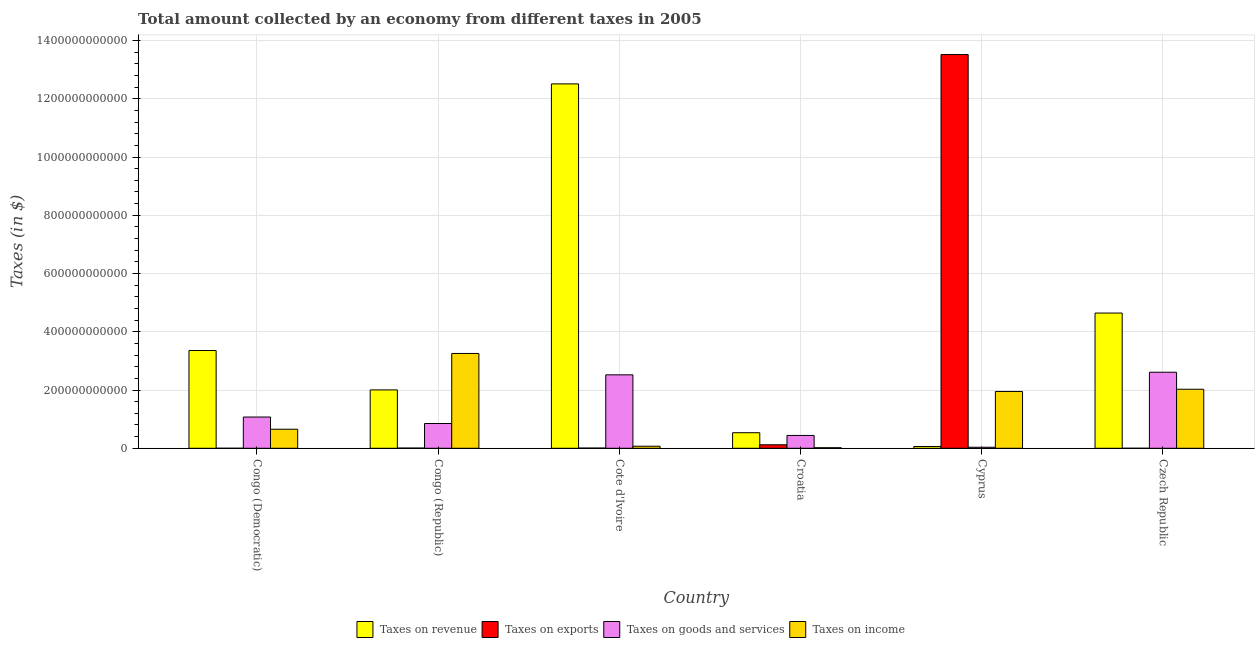How many different coloured bars are there?
Provide a succinct answer. 4. Are the number of bars per tick equal to the number of legend labels?
Ensure brevity in your answer.  Yes. Are the number of bars on each tick of the X-axis equal?
Make the answer very short. Yes. What is the label of the 4th group of bars from the left?
Ensure brevity in your answer.  Croatia. What is the amount collected as tax on income in Croatia?
Your answer should be compact. 1.96e+09. Across all countries, what is the maximum amount collected as tax on goods?
Make the answer very short. 2.61e+11. Across all countries, what is the minimum amount collected as tax on exports?
Give a very brief answer. 1.00e+06. In which country was the amount collected as tax on exports maximum?
Provide a short and direct response. Cyprus. In which country was the amount collected as tax on exports minimum?
Your answer should be compact. Czech Republic. What is the total amount collected as tax on exports in the graph?
Give a very brief answer. 1.37e+12. What is the difference between the amount collected as tax on goods in Congo (Democratic) and that in Czech Republic?
Keep it short and to the point. -1.54e+11. What is the difference between the amount collected as tax on exports in Congo (Republic) and the amount collected as tax on goods in Cyprus?
Offer a very short reply. -2.79e+09. What is the average amount collected as tax on revenue per country?
Your answer should be very brief. 3.85e+11. What is the difference between the amount collected as tax on income and amount collected as tax on revenue in Congo (Republic)?
Offer a very short reply. 1.25e+11. What is the ratio of the amount collected as tax on income in Croatia to that in Czech Republic?
Your answer should be very brief. 0.01. Is the amount collected as tax on exports in Cote d'Ivoire less than that in Cyprus?
Provide a short and direct response. Yes. Is the difference between the amount collected as tax on revenue in Cote d'Ivoire and Croatia greater than the difference between the amount collected as tax on exports in Cote d'Ivoire and Croatia?
Keep it short and to the point. Yes. What is the difference between the highest and the second highest amount collected as tax on goods?
Give a very brief answer. 8.94e+09. What is the difference between the highest and the lowest amount collected as tax on goods?
Ensure brevity in your answer.  2.58e+11. Is the sum of the amount collected as tax on income in Cote d'Ivoire and Cyprus greater than the maximum amount collected as tax on exports across all countries?
Provide a succinct answer. No. What does the 1st bar from the left in Cyprus represents?
Provide a short and direct response. Taxes on revenue. What does the 3rd bar from the right in Croatia represents?
Your answer should be very brief. Taxes on exports. Is it the case that in every country, the sum of the amount collected as tax on revenue and amount collected as tax on exports is greater than the amount collected as tax on goods?
Your answer should be compact. Yes. How many bars are there?
Your answer should be very brief. 24. What is the difference between two consecutive major ticks on the Y-axis?
Your answer should be very brief. 2.00e+11. Are the values on the major ticks of Y-axis written in scientific E-notation?
Provide a short and direct response. No. How are the legend labels stacked?
Offer a terse response. Horizontal. What is the title of the graph?
Provide a succinct answer. Total amount collected by an economy from different taxes in 2005. Does "Rule based governance" appear as one of the legend labels in the graph?
Your response must be concise. No. What is the label or title of the X-axis?
Keep it short and to the point. Country. What is the label or title of the Y-axis?
Provide a short and direct response. Taxes (in $). What is the Taxes (in $) in Taxes on revenue in Congo (Democratic)?
Offer a terse response. 3.36e+11. What is the Taxes (in $) in Taxes on exports in Congo (Democratic)?
Keep it short and to the point. 8.52e+06. What is the Taxes (in $) in Taxes on goods and services in Congo (Democratic)?
Provide a short and direct response. 1.07e+11. What is the Taxes (in $) in Taxes on income in Congo (Democratic)?
Your answer should be very brief. 6.54e+1. What is the Taxes (in $) of Taxes on revenue in Congo (Republic)?
Offer a very short reply. 2.00e+11. What is the Taxes (in $) of Taxes on exports in Congo (Republic)?
Your answer should be very brief. 7.10e+08. What is the Taxes (in $) in Taxes on goods and services in Congo (Republic)?
Ensure brevity in your answer.  8.51e+1. What is the Taxes (in $) of Taxes on income in Congo (Republic)?
Offer a terse response. 3.26e+11. What is the Taxes (in $) of Taxes on revenue in Cote d'Ivoire?
Provide a short and direct response. 1.25e+12. What is the Taxes (in $) in Taxes on exports in Cote d'Ivoire?
Offer a terse response. 6.98e+08. What is the Taxes (in $) of Taxes on goods and services in Cote d'Ivoire?
Give a very brief answer. 2.52e+11. What is the Taxes (in $) of Taxes on income in Cote d'Ivoire?
Keep it short and to the point. 7.06e+09. What is the Taxes (in $) in Taxes on revenue in Croatia?
Your answer should be compact. 5.34e+1. What is the Taxes (in $) of Taxes on exports in Croatia?
Offer a terse response. 1.20e+1. What is the Taxes (in $) in Taxes on goods and services in Croatia?
Provide a succinct answer. 4.41e+1. What is the Taxes (in $) of Taxes on income in Croatia?
Provide a short and direct response. 1.96e+09. What is the Taxes (in $) in Taxes on revenue in Cyprus?
Provide a succinct answer. 6.12e+09. What is the Taxes (in $) of Taxes on exports in Cyprus?
Your response must be concise. 1.35e+12. What is the Taxes (in $) of Taxes on goods and services in Cyprus?
Keep it short and to the point. 3.50e+09. What is the Taxes (in $) of Taxes on income in Cyprus?
Provide a short and direct response. 1.95e+11. What is the Taxes (in $) in Taxes on revenue in Czech Republic?
Provide a succinct answer. 4.64e+11. What is the Taxes (in $) in Taxes on exports in Czech Republic?
Offer a terse response. 1.00e+06. What is the Taxes (in $) in Taxes on goods and services in Czech Republic?
Offer a very short reply. 2.61e+11. What is the Taxes (in $) in Taxes on income in Czech Republic?
Keep it short and to the point. 2.03e+11. Across all countries, what is the maximum Taxes (in $) of Taxes on revenue?
Keep it short and to the point. 1.25e+12. Across all countries, what is the maximum Taxes (in $) of Taxes on exports?
Your answer should be compact. 1.35e+12. Across all countries, what is the maximum Taxes (in $) in Taxes on goods and services?
Provide a succinct answer. 2.61e+11. Across all countries, what is the maximum Taxes (in $) in Taxes on income?
Provide a succinct answer. 3.26e+11. Across all countries, what is the minimum Taxes (in $) of Taxes on revenue?
Provide a succinct answer. 6.12e+09. Across all countries, what is the minimum Taxes (in $) of Taxes on exports?
Offer a very short reply. 1.00e+06. Across all countries, what is the minimum Taxes (in $) of Taxes on goods and services?
Make the answer very short. 3.50e+09. Across all countries, what is the minimum Taxes (in $) of Taxes on income?
Give a very brief answer. 1.96e+09. What is the total Taxes (in $) of Taxes on revenue in the graph?
Provide a succinct answer. 2.31e+12. What is the total Taxes (in $) of Taxes on exports in the graph?
Keep it short and to the point. 1.37e+12. What is the total Taxes (in $) in Taxes on goods and services in the graph?
Your answer should be very brief. 7.53e+11. What is the total Taxes (in $) of Taxes on income in the graph?
Your answer should be compact. 7.98e+11. What is the difference between the Taxes (in $) in Taxes on revenue in Congo (Democratic) and that in Congo (Republic)?
Ensure brevity in your answer.  1.35e+11. What is the difference between the Taxes (in $) in Taxes on exports in Congo (Democratic) and that in Congo (Republic)?
Keep it short and to the point. -7.01e+08. What is the difference between the Taxes (in $) in Taxes on goods and services in Congo (Democratic) and that in Congo (Republic)?
Your answer should be compact. 2.23e+1. What is the difference between the Taxes (in $) of Taxes on income in Congo (Democratic) and that in Congo (Republic)?
Your answer should be compact. -2.60e+11. What is the difference between the Taxes (in $) in Taxes on revenue in Congo (Democratic) and that in Cote d'Ivoire?
Your answer should be compact. -9.15e+11. What is the difference between the Taxes (in $) of Taxes on exports in Congo (Democratic) and that in Cote d'Ivoire?
Make the answer very short. -6.89e+08. What is the difference between the Taxes (in $) in Taxes on goods and services in Congo (Democratic) and that in Cote d'Ivoire?
Keep it short and to the point. -1.45e+11. What is the difference between the Taxes (in $) in Taxes on income in Congo (Democratic) and that in Cote d'Ivoire?
Keep it short and to the point. 5.84e+1. What is the difference between the Taxes (in $) in Taxes on revenue in Congo (Democratic) and that in Croatia?
Provide a short and direct response. 2.82e+11. What is the difference between the Taxes (in $) in Taxes on exports in Congo (Democratic) and that in Croatia?
Make the answer very short. -1.20e+1. What is the difference between the Taxes (in $) in Taxes on goods and services in Congo (Democratic) and that in Croatia?
Ensure brevity in your answer.  6.32e+1. What is the difference between the Taxes (in $) in Taxes on income in Congo (Democratic) and that in Croatia?
Ensure brevity in your answer.  6.35e+1. What is the difference between the Taxes (in $) in Taxes on revenue in Congo (Democratic) and that in Cyprus?
Ensure brevity in your answer.  3.30e+11. What is the difference between the Taxes (in $) in Taxes on exports in Congo (Democratic) and that in Cyprus?
Your response must be concise. -1.35e+12. What is the difference between the Taxes (in $) of Taxes on goods and services in Congo (Democratic) and that in Cyprus?
Provide a succinct answer. 1.04e+11. What is the difference between the Taxes (in $) in Taxes on income in Congo (Democratic) and that in Cyprus?
Your answer should be compact. -1.30e+11. What is the difference between the Taxes (in $) of Taxes on revenue in Congo (Democratic) and that in Czech Republic?
Make the answer very short. -1.29e+11. What is the difference between the Taxes (in $) of Taxes on exports in Congo (Democratic) and that in Czech Republic?
Offer a terse response. 7.52e+06. What is the difference between the Taxes (in $) in Taxes on goods and services in Congo (Democratic) and that in Czech Republic?
Provide a succinct answer. -1.54e+11. What is the difference between the Taxes (in $) of Taxes on income in Congo (Democratic) and that in Czech Republic?
Your answer should be very brief. -1.37e+11. What is the difference between the Taxes (in $) of Taxes on revenue in Congo (Republic) and that in Cote d'Ivoire?
Your answer should be very brief. -1.05e+12. What is the difference between the Taxes (in $) of Taxes on exports in Congo (Republic) and that in Cote d'Ivoire?
Give a very brief answer. 1.20e+07. What is the difference between the Taxes (in $) in Taxes on goods and services in Congo (Republic) and that in Cote d'Ivoire?
Make the answer very short. -1.67e+11. What is the difference between the Taxes (in $) in Taxes on income in Congo (Republic) and that in Cote d'Ivoire?
Your response must be concise. 3.19e+11. What is the difference between the Taxes (in $) in Taxes on revenue in Congo (Republic) and that in Croatia?
Your response must be concise. 1.47e+11. What is the difference between the Taxes (in $) of Taxes on exports in Congo (Republic) and that in Croatia?
Offer a very short reply. -1.13e+1. What is the difference between the Taxes (in $) of Taxes on goods and services in Congo (Republic) and that in Croatia?
Provide a succinct answer. 4.10e+1. What is the difference between the Taxes (in $) in Taxes on income in Congo (Republic) and that in Croatia?
Provide a succinct answer. 3.24e+11. What is the difference between the Taxes (in $) in Taxes on revenue in Congo (Republic) and that in Cyprus?
Ensure brevity in your answer.  1.94e+11. What is the difference between the Taxes (in $) of Taxes on exports in Congo (Republic) and that in Cyprus?
Keep it short and to the point. -1.35e+12. What is the difference between the Taxes (in $) in Taxes on goods and services in Congo (Republic) and that in Cyprus?
Provide a short and direct response. 8.16e+1. What is the difference between the Taxes (in $) of Taxes on income in Congo (Republic) and that in Cyprus?
Provide a succinct answer. 1.31e+11. What is the difference between the Taxes (in $) of Taxes on revenue in Congo (Republic) and that in Czech Republic?
Provide a succinct answer. -2.64e+11. What is the difference between the Taxes (in $) in Taxes on exports in Congo (Republic) and that in Czech Republic?
Offer a very short reply. 7.09e+08. What is the difference between the Taxes (in $) of Taxes on goods and services in Congo (Republic) and that in Czech Republic?
Offer a very short reply. -1.76e+11. What is the difference between the Taxes (in $) in Taxes on income in Congo (Republic) and that in Czech Republic?
Provide a succinct answer. 1.23e+11. What is the difference between the Taxes (in $) in Taxes on revenue in Cote d'Ivoire and that in Croatia?
Your answer should be compact. 1.20e+12. What is the difference between the Taxes (in $) of Taxes on exports in Cote d'Ivoire and that in Croatia?
Keep it short and to the point. -1.13e+1. What is the difference between the Taxes (in $) in Taxes on goods and services in Cote d'Ivoire and that in Croatia?
Your response must be concise. 2.08e+11. What is the difference between the Taxes (in $) of Taxes on income in Cote d'Ivoire and that in Croatia?
Give a very brief answer. 5.10e+09. What is the difference between the Taxes (in $) of Taxes on revenue in Cote d'Ivoire and that in Cyprus?
Ensure brevity in your answer.  1.25e+12. What is the difference between the Taxes (in $) of Taxes on exports in Cote d'Ivoire and that in Cyprus?
Give a very brief answer. -1.35e+12. What is the difference between the Taxes (in $) in Taxes on goods and services in Cote d'Ivoire and that in Cyprus?
Offer a terse response. 2.49e+11. What is the difference between the Taxes (in $) of Taxes on income in Cote d'Ivoire and that in Cyprus?
Ensure brevity in your answer.  -1.88e+11. What is the difference between the Taxes (in $) in Taxes on revenue in Cote d'Ivoire and that in Czech Republic?
Provide a short and direct response. 7.87e+11. What is the difference between the Taxes (in $) of Taxes on exports in Cote d'Ivoire and that in Czech Republic?
Give a very brief answer. 6.97e+08. What is the difference between the Taxes (in $) in Taxes on goods and services in Cote d'Ivoire and that in Czech Republic?
Offer a very short reply. -8.94e+09. What is the difference between the Taxes (in $) of Taxes on income in Cote d'Ivoire and that in Czech Republic?
Ensure brevity in your answer.  -1.96e+11. What is the difference between the Taxes (in $) of Taxes on revenue in Croatia and that in Cyprus?
Keep it short and to the point. 4.73e+1. What is the difference between the Taxes (in $) in Taxes on exports in Croatia and that in Cyprus?
Your answer should be very brief. -1.34e+12. What is the difference between the Taxes (in $) in Taxes on goods and services in Croatia and that in Cyprus?
Ensure brevity in your answer.  4.06e+1. What is the difference between the Taxes (in $) in Taxes on income in Croatia and that in Cyprus?
Your answer should be very brief. -1.93e+11. What is the difference between the Taxes (in $) in Taxes on revenue in Croatia and that in Czech Republic?
Ensure brevity in your answer.  -4.11e+11. What is the difference between the Taxes (in $) of Taxes on exports in Croatia and that in Czech Republic?
Make the answer very short. 1.20e+1. What is the difference between the Taxes (in $) of Taxes on goods and services in Croatia and that in Czech Republic?
Your answer should be very brief. -2.17e+11. What is the difference between the Taxes (in $) in Taxes on income in Croatia and that in Czech Republic?
Offer a very short reply. -2.01e+11. What is the difference between the Taxes (in $) in Taxes on revenue in Cyprus and that in Czech Republic?
Provide a short and direct response. -4.58e+11. What is the difference between the Taxes (in $) in Taxes on exports in Cyprus and that in Czech Republic?
Your answer should be compact. 1.35e+12. What is the difference between the Taxes (in $) in Taxes on goods and services in Cyprus and that in Czech Republic?
Your answer should be very brief. -2.58e+11. What is the difference between the Taxes (in $) in Taxes on income in Cyprus and that in Czech Republic?
Provide a short and direct response. -7.66e+09. What is the difference between the Taxes (in $) in Taxes on revenue in Congo (Democratic) and the Taxes (in $) in Taxes on exports in Congo (Republic)?
Keep it short and to the point. 3.35e+11. What is the difference between the Taxes (in $) in Taxes on revenue in Congo (Democratic) and the Taxes (in $) in Taxes on goods and services in Congo (Republic)?
Keep it short and to the point. 2.51e+11. What is the difference between the Taxes (in $) in Taxes on revenue in Congo (Democratic) and the Taxes (in $) in Taxes on income in Congo (Republic)?
Offer a very short reply. 1.01e+1. What is the difference between the Taxes (in $) of Taxes on exports in Congo (Democratic) and the Taxes (in $) of Taxes on goods and services in Congo (Republic)?
Make the answer very short. -8.51e+1. What is the difference between the Taxes (in $) of Taxes on exports in Congo (Democratic) and the Taxes (in $) of Taxes on income in Congo (Republic)?
Offer a very short reply. -3.26e+11. What is the difference between the Taxes (in $) of Taxes on goods and services in Congo (Democratic) and the Taxes (in $) of Taxes on income in Congo (Republic)?
Offer a very short reply. -2.18e+11. What is the difference between the Taxes (in $) in Taxes on revenue in Congo (Democratic) and the Taxes (in $) in Taxes on exports in Cote d'Ivoire?
Provide a succinct answer. 3.35e+11. What is the difference between the Taxes (in $) in Taxes on revenue in Congo (Democratic) and the Taxes (in $) in Taxes on goods and services in Cote d'Ivoire?
Your answer should be very brief. 8.35e+1. What is the difference between the Taxes (in $) of Taxes on revenue in Congo (Democratic) and the Taxes (in $) of Taxes on income in Cote d'Ivoire?
Your answer should be compact. 3.29e+11. What is the difference between the Taxes (in $) in Taxes on exports in Congo (Democratic) and the Taxes (in $) in Taxes on goods and services in Cote d'Ivoire?
Offer a very short reply. -2.52e+11. What is the difference between the Taxes (in $) in Taxes on exports in Congo (Democratic) and the Taxes (in $) in Taxes on income in Cote d'Ivoire?
Offer a terse response. -7.05e+09. What is the difference between the Taxes (in $) in Taxes on goods and services in Congo (Democratic) and the Taxes (in $) in Taxes on income in Cote d'Ivoire?
Provide a short and direct response. 1.00e+11. What is the difference between the Taxes (in $) in Taxes on revenue in Congo (Democratic) and the Taxes (in $) in Taxes on exports in Croatia?
Your response must be concise. 3.24e+11. What is the difference between the Taxes (in $) in Taxes on revenue in Congo (Democratic) and the Taxes (in $) in Taxes on goods and services in Croatia?
Provide a short and direct response. 2.92e+11. What is the difference between the Taxes (in $) in Taxes on revenue in Congo (Democratic) and the Taxes (in $) in Taxes on income in Croatia?
Your response must be concise. 3.34e+11. What is the difference between the Taxes (in $) in Taxes on exports in Congo (Democratic) and the Taxes (in $) in Taxes on goods and services in Croatia?
Give a very brief answer. -4.41e+1. What is the difference between the Taxes (in $) in Taxes on exports in Congo (Democratic) and the Taxes (in $) in Taxes on income in Croatia?
Keep it short and to the point. -1.95e+09. What is the difference between the Taxes (in $) in Taxes on goods and services in Congo (Democratic) and the Taxes (in $) in Taxes on income in Croatia?
Your response must be concise. 1.05e+11. What is the difference between the Taxes (in $) in Taxes on revenue in Congo (Democratic) and the Taxes (in $) in Taxes on exports in Cyprus?
Offer a very short reply. -1.02e+12. What is the difference between the Taxes (in $) in Taxes on revenue in Congo (Democratic) and the Taxes (in $) in Taxes on goods and services in Cyprus?
Keep it short and to the point. 3.32e+11. What is the difference between the Taxes (in $) of Taxes on revenue in Congo (Democratic) and the Taxes (in $) of Taxes on income in Cyprus?
Offer a very short reply. 1.41e+11. What is the difference between the Taxes (in $) of Taxes on exports in Congo (Democratic) and the Taxes (in $) of Taxes on goods and services in Cyprus?
Provide a short and direct response. -3.49e+09. What is the difference between the Taxes (in $) in Taxes on exports in Congo (Democratic) and the Taxes (in $) in Taxes on income in Cyprus?
Ensure brevity in your answer.  -1.95e+11. What is the difference between the Taxes (in $) in Taxes on goods and services in Congo (Democratic) and the Taxes (in $) in Taxes on income in Cyprus?
Your response must be concise. -8.77e+1. What is the difference between the Taxes (in $) of Taxes on revenue in Congo (Democratic) and the Taxes (in $) of Taxes on exports in Czech Republic?
Your answer should be very brief. 3.36e+11. What is the difference between the Taxes (in $) in Taxes on revenue in Congo (Democratic) and the Taxes (in $) in Taxes on goods and services in Czech Republic?
Provide a succinct answer. 7.46e+1. What is the difference between the Taxes (in $) in Taxes on revenue in Congo (Democratic) and the Taxes (in $) in Taxes on income in Czech Republic?
Make the answer very short. 1.33e+11. What is the difference between the Taxes (in $) of Taxes on exports in Congo (Democratic) and the Taxes (in $) of Taxes on goods and services in Czech Republic?
Keep it short and to the point. -2.61e+11. What is the difference between the Taxes (in $) in Taxes on exports in Congo (Democratic) and the Taxes (in $) in Taxes on income in Czech Republic?
Provide a succinct answer. -2.03e+11. What is the difference between the Taxes (in $) in Taxes on goods and services in Congo (Democratic) and the Taxes (in $) in Taxes on income in Czech Republic?
Ensure brevity in your answer.  -9.54e+1. What is the difference between the Taxes (in $) in Taxes on revenue in Congo (Republic) and the Taxes (in $) in Taxes on exports in Cote d'Ivoire?
Offer a very short reply. 2.00e+11. What is the difference between the Taxes (in $) of Taxes on revenue in Congo (Republic) and the Taxes (in $) of Taxes on goods and services in Cote d'Ivoire?
Your response must be concise. -5.18e+1. What is the difference between the Taxes (in $) of Taxes on revenue in Congo (Republic) and the Taxes (in $) of Taxes on income in Cote d'Ivoire?
Ensure brevity in your answer.  1.93e+11. What is the difference between the Taxes (in $) of Taxes on exports in Congo (Republic) and the Taxes (in $) of Taxes on goods and services in Cote d'Ivoire?
Keep it short and to the point. -2.51e+11. What is the difference between the Taxes (in $) of Taxes on exports in Congo (Republic) and the Taxes (in $) of Taxes on income in Cote d'Ivoire?
Provide a short and direct response. -6.35e+09. What is the difference between the Taxes (in $) in Taxes on goods and services in Congo (Republic) and the Taxes (in $) in Taxes on income in Cote d'Ivoire?
Make the answer very short. 7.80e+1. What is the difference between the Taxes (in $) of Taxes on revenue in Congo (Republic) and the Taxes (in $) of Taxes on exports in Croatia?
Provide a short and direct response. 1.88e+11. What is the difference between the Taxes (in $) of Taxes on revenue in Congo (Republic) and the Taxes (in $) of Taxes on goods and services in Croatia?
Your response must be concise. 1.56e+11. What is the difference between the Taxes (in $) of Taxes on revenue in Congo (Republic) and the Taxes (in $) of Taxes on income in Croatia?
Your answer should be compact. 1.98e+11. What is the difference between the Taxes (in $) in Taxes on exports in Congo (Republic) and the Taxes (in $) in Taxes on goods and services in Croatia?
Offer a terse response. -4.34e+1. What is the difference between the Taxes (in $) in Taxes on exports in Congo (Republic) and the Taxes (in $) in Taxes on income in Croatia?
Give a very brief answer. -1.25e+09. What is the difference between the Taxes (in $) of Taxes on goods and services in Congo (Republic) and the Taxes (in $) of Taxes on income in Croatia?
Offer a very short reply. 8.31e+1. What is the difference between the Taxes (in $) of Taxes on revenue in Congo (Republic) and the Taxes (in $) of Taxes on exports in Cyprus?
Your answer should be very brief. -1.15e+12. What is the difference between the Taxes (in $) of Taxes on revenue in Congo (Republic) and the Taxes (in $) of Taxes on goods and services in Cyprus?
Ensure brevity in your answer.  1.97e+11. What is the difference between the Taxes (in $) in Taxes on revenue in Congo (Republic) and the Taxes (in $) in Taxes on income in Cyprus?
Your answer should be compact. 5.37e+09. What is the difference between the Taxes (in $) in Taxes on exports in Congo (Republic) and the Taxes (in $) in Taxes on goods and services in Cyprus?
Your response must be concise. -2.79e+09. What is the difference between the Taxes (in $) of Taxes on exports in Congo (Republic) and the Taxes (in $) of Taxes on income in Cyprus?
Your answer should be compact. -1.94e+11. What is the difference between the Taxes (in $) in Taxes on goods and services in Congo (Republic) and the Taxes (in $) in Taxes on income in Cyprus?
Offer a very short reply. -1.10e+11. What is the difference between the Taxes (in $) in Taxes on revenue in Congo (Republic) and the Taxes (in $) in Taxes on exports in Czech Republic?
Make the answer very short. 2.00e+11. What is the difference between the Taxes (in $) in Taxes on revenue in Congo (Republic) and the Taxes (in $) in Taxes on goods and services in Czech Republic?
Provide a short and direct response. -6.07e+1. What is the difference between the Taxes (in $) of Taxes on revenue in Congo (Republic) and the Taxes (in $) of Taxes on income in Czech Republic?
Your response must be concise. -2.29e+09. What is the difference between the Taxes (in $) in Taxes on exports in Congo (Republic) and the Taxes (in $) in Taxes on goods and services in Czech Republic?
Make the answer very short. -2.60e+11. What is the difference between the Taxes (in $) of Taxes on exports in Congo (Republic) and the Taxes (in $) of Taxes on income in Czech Republic?
Provide a succinct answer. -2.02e+11. What is the difference between the Taxes (in $) of Taxes on goods and services in Congo (Republic) and the Taxes (in $) of Taxes on income in Czech Republic?
Ensure brevity in your answer.  -1.18e+11. What is the difference between the Taxes (in $) of Taxes on revenue in Cote d'Ivoire and the Taxes (in $) of Taxes on exports in Croatia?
Make the answer very short. 1.24e+12. What is the difference between the Taxes (in $) of Taxes on revenue in Cote d'Ivoire and the Taxes (in $) of Taxes on goods and services in Croatia?
Keep it short and to the point. 1.21e+12. What is the difference between the Taxes (in $) of Taxes on revenue in Cote d'Ivoire and the Taxes (in $) of Taxes on income in Croatia?
Give a very brief answer. 1.25e+12. What is the difference between the Taxes (in $) of Taxes on exports in Cote d'Ivoire and the Taxes (in $) of Taxes on goods and services in Croatia?
Your answer should be compact. -4.34e+1. What is the difference between the Taxes (in $) in Taxes on exports in Cote d'Ivoire and the Taxes (in $) in Taxes on income in Croatia?
Provide a succinct answer. -1.26e+09. What is the difference between the Taxes (in $) of Taxes on goods and services in Cote d'Ivoire and the Taxes (in $) of Taxes on income in Croatia?
Make the answer very short. 2.50e+11. What is the difference between the Taxes (in $) of Taxes on revenue in Cote d'Ivoire and the Taxes (in $) of Taxes on exports in Cyprus?
Make the answer very short. -1.01e+11. What is the difference between the Taxes (in $) of Taxes on revenue in Cote d'Ivoire and the Taxes (in $) of Taxes on goods and services in Cyprus?
Provide a short and direct response. 1.25e+12. What is the difference between the Taxes (in $) of Taxes on revenue in Cote d'Ivoire and the Taxes (in $) of Taxes on income in Cyprus?
Keep it short and to the point. 1.06e+12. What is the difference between the Taxes (in $) of Taxes on exports in Cote d'Ivoire and the Taxes (in $) of Taxes on goods and services in Cyprus?
Give a very brief answer. -2.81e+09. What is the difference between the Taxes (in $) of Taxes on exports in Cote d'Ivoire and the Taxes (in $) of Taxes on income in Cyprus?
Provide a succinct answer. -1.94e+11. What is the difference between the Taxes (in $) of Taxes on goods and services in Cote d'Ivoire and the Taxes (in $) of Taxes on income in Cyprus?
Offer a terse response. 5.71e+1. What is the difference between the Taxes (in $) of Taxes on revenue in Cote d'Ivoire and the Taxes (in $) of Taxes on exports in Czech Republic?
Ensure brevity in your answer.  1.25e+12. What is the difference between the Taxes (in $) of Taxes on revenue in Cote d'Ivoire and the Taxes (in $) of Taxes on goods and services in Czech Republic?
Your answer should be very brief. 9.90e+11. What is the difference between the Taxes (in $) in Taxes on revenue in Cote d'Ivoire and the Taxes (in $) in Taxes on income in Czech Republic?
Ensure brevity in your answer.  1.05e+12. What is the difference between the Taxes (in $) in Taxes on exports in Cote d'Ivoire and the Taxes (in $) in Taxes on goods and services in Czech Republic?
Ensure brevity in your answer.  -2.60e+11. What is the difference between the Taxes (in $) of Taxes on exports in Cote d'Ivoire and the Taxes (in $) of Taxes on income in Czech Republic?
Make the answer very short. -2.02e+11. What is the difference between the Taxes (in $) of Taxes on goods and services in Cote d'Ivoire and the Taxes (in $) of Taxes on income in Czech Republic?
Ensure brevity in your answer.  4.95e+1. What is the difference between the Taxes (in $) of Taxes on revenue in Croatia and the Taxes (in $) of Taxes on exports in Cyprus?
Offer a very short reply. -1.30e+12. What is the difference between the Taxes (in $) in Taxes on revenue in Croatia and the Taxes (in $) in Taxes on goods and services in Cyprus?
Keep it short and to the point. 4.99e+1. What is the difference between the Taxes (in $) in Taxes on revenue in Croatia and the Taxes (in $) in Taxes on income in Cyprus?
Ensure brevity in your answer.  -1.42e+11. What is the difference between the Taxes (in $) in Taxes on exports in Croatia and the Taxes (in $) in Taxes on goods and services in Cyprus?
Your answer should be compact. 8.51e+09. What is the difference between the Taxes (in $) in Taxes on exports in Croatia and the Taxes (in $) in Taxes on income in Cyprus?
Offer a terse response. -1.83e+11. What is the difference between the Taxes (in $) in Taxes on goods and services in Croatia and the Taxes (in $) in Taxes on income in Cyprus?
Offer a very short reply. -1.51e+11. What is the difference between the Taxes (in $) in Taxes on revenue in Croatia and the Taxes (in $) in Taxes on exports in Czech Republic?
Your answer should be compact. 5.34e+1. What is the difference between the Taxes (in $) in Taxes on revenue in Croatia and the Taxes (in $) in Taxes on goods and services in Czech Republic?
Give a very brief answer. -2.08e+11. What is the difference between the Taxes (in $) of Taxes on revenue in Croatia and the Taxes (in $) of Taxes on income in Czech Republic?
Offer a very short reply. -1.49e+11. What is the difference between the Taxes (in $) of Taxes on exports in Croatia and the Taxes (in $) of Taxes on goods and services in Czech Republic?
Give a very brief answer. -2.49e+11. What is the difference between the Taxes (in $) of Taxes on exports in Croatia and the Taxes (in $) of Taxes on income in Czech Republic?
Offer a very short reply. -1.91e+11. What is the difference between the Taxes (in $) of Taxes on goods and services in Croatia and the Taxes (in $) of Taxes on income in Czech Republic?
Provide a succinct answer. -1.59e+11. What is the difference between the Taxes (in $) in Taxes on revenue in Cyprus and the Taxes (in $) in Taxes on exports in Czech Republic?
Give a very brief answer. 6.12e+09. What is the difference between the Taxes (in $) of Taxes on revenue in Cyprus and the Taxes (in $) of Taxes on goods and services in Czech Republic?
Your answer should be compact. -2.55e+11. What is the difference between the Taxes (in $) of Taxes on revenue in Cyprus and the Taxes (in $) of Taxes on income in Czech Republic?
Your answer should be compact. -1.97e+11. What is the difference between the Taxes (in $) in Taxes on exports in Cyprus and the Taxes (in $) in Taxes on goods and services in Czech Republic?
Offer a very short reply. 1.09e+12. What is the difference between the Taxes (in $) in Taxes on exports in Cyprus and the Taxes (in $) in Taxes on income in Czech Republic?
Provide a succinct answer. 1.15e+12. What is the difference between the Taxes (in $) in Taxes on goods and services in Cyprus and the Taxes (in $) in Taxes on income in Czech Republic?
Offer a very short reply. -1.99e+11. What is the average Taxes (in $) of Taxes on revenue per country?
Keep it short and to the point. 3.85e+11. What is the average Taxes (in $) in Taxes on exports per country?
Offer a very short reply. 2.28e+11. What is the average Taxes (in $) in Taxes on goods and services per country?
Ensure brevity in your answer.  1.26e+11. What is the average Taxes (in $) of Taxes on income per country?
Offer a terse response. 1.33e+11. What is the difference between the Taxes (in $) in Taxes on revenue and Taxes (in $) in Taxes on exports in Congo (Democratic)?
Your answer should be compact. 3.36e+11. What is the difference between the Taxes (in $) in Taxes on revenue and Taxes (in $) in Taxes on goods and services in Congo (Democratic)?
Provide a succinct answer. 2.28e+11. What is the difference between the Taxes (in $) in Taxes on revenue and Taxes (in $) in Taxes on income in Congo (Democratic)?
Provide a succinct answer. 2.70e+11. What is the difference between the Taxes (in $) in Taxes on exports and Taxes (in $) in Taxes on goods and services in Congo (Democratic)?
Provide a succinct answer. -1.07e+11. What is the difference between the Taxes (in $) in Taxes on exports and Taxes (in $) in Taxes on income in Congo (Democratic)?
Provide a short and direct response. -6.54e+1. What is the difference between the Taxes (in $) in Taxes on goods and services and Taxes (in $) in Taxes on income in Congo (Democratic)?
Your answer should be very brief. 4.19e+1. What is the difference between the Taxes (in $) of Taxes on revenue and Taxes (in $) of Taxes on exports in Congo (Republic)?
Your answer should be compact. 2.00e+11. What is the difference between the Taxes (in $) in Taxes on revenue and Taxes (in $) in Taxes on goods and services in Congo (Republic)?
Make the answer very short. 1.15e+11. What is the difference between the Taxes (in $) in Taxes on revenue and Taxes (in $) in Taxes on income in Congo (Republic)?
Your answer should be compact. -1.25e+11. What is the difference between the Taxes (in $) in Taxes on exports and Taxes (in $) in Taxes on goods and services in Congo (Republic)?
Provide a short and direct response. -8.44e+1. What is the difference between the Taxes (in $) in Taxes on exports and Taxes (in $) in Taxes on income in Congo (Republic)?
Offer a very short reply. -3.25e+11. What is the difference between the Taxes (in $) in Taxes on goods and services and Taxes (in $) in Taxes on income in Congo (Republic)?
Your response must be concise. -2.41e+11. What is the difference between the Taxes (in $) of Taxes on revenue and Taxes (in $) of Taxes on exports in Cote d'Ivoire?
Keep it short and to the point. 1.25e+12. What is the difference between the Taxes (in $) in Taxes on revenue and Taxes (in $) in Taxes on goods and services in Cote d'Ivoire?
Offer a very short reply. 9.99e+11. What is the difference between the Taxes (in $) in Taxes on revenue and Taxes (in $) in Taxes on income in Cote d'Ivoire?
Ensure brevity in your answer.  1.24e+12. What is the difference between the Taxes (in $) of Taxes on exports and Taxes (in $) of Taxes on goods and services in Cote d'Ivoire?
Provide a succinct answer. -2.52e+11. What is the difference between the Taxes (in $) in Taxes on exports and Taxes (in $) in Taxes on income in Cote d'Ivoire?
Your response must be concise. -6.36e+09. What is the difference between the Taxes (in $) in Taxes on goods and services and Taxes (in $) in Taxes on income in Cote d'Ivoire?
Your answer should be compact. 2.45e+11. What is the difference between the Taxes (in $) in Taxes on revenue and Taxes (in $) in Taxes on exports in Croatia?
Provide a short and direct response. 4.14e+1. What is the difference between the Taxes (in $) of Taxes on revenue and Taxes (in $) of Taxes on goods and services in Croatia?
Provide a short and direct response. 9.36e+09. What is the difference between the Taxes (in $) of Taxes on revenue and Taxes (in $) of Taxes on income in Croatia?
Keep it short and to the point. 5.15e+1. What is the difference between the Taxes (in $) of Taxes on exports and Taxes (in $) of Taxes on goods and services in Croatia?
Offer a very short reply. -3.21e+1. What is the difference between the Taxes (in $) in Taxes on exports and Taxes (in $) in Taxes on income in Croatia?
Offer a terse response. 1.01e+1. What is the difference between the Taxes (in $) of Taxes on goods and services and Taxes (in $) of Taxes on income in Croatia?
Make the answer very short. 4.21e+1. What is the difference between the Taxes (in $) of Taxes on revenue and Taxes (in $) of Taxes on exports in Cyprus?
Ensure brevity in your answer.  -1.35e+12. What is the difference between the Taxes (in $) in Taxes on revenue and Taxes (in $) in Taxes on goods and services in Cyprus?
Offer a terse response. 2.61e+09. What is the difference between the Taxes (in $) in Taxes on revenue and Taxes (in $) in Taxes on income in Cyprus?
Make the answer very short. -1.89e+11. What is the difference between the Taxes (in $) of Taxes on exports and Taxes (in $) of Taxes on goods and services in Cyprus?
Your answer should be very brief. 1.35e+12. What is the difference between the Taxes (in $) of Taxes on exports and Taxes (in $) of Taxes on income in Cyprus?
Make the answer very short. 1.16e+12. What is the difference between the Taxes (in $) in Taxes on goods and services and Taxes (in $) in Taxes on income in Cyprus?
Give a very brief answer. -1.92e+11. What is the difference between the Taxes (in $) in Taxes on revenue and Taxes (in $) in Taxes on exports in Czech Republic?
Ensure brevity in your answer.  4.64e+11. What is the difference between the Taxes (in $) of Taxes on revenue and Taxes (in $) of Taxes on goods and services in Czech Republic?
Make the answer very short. 2.03e+11. What is the difference between the Taxes (in $) in Taxes on revenue and Taxes (in $) in Taxes on income in Czech Republic?
Make the answer very short. 2.62e+11. What is the difference between the Taxes (in $) in Taxes on exports and Taxes (in $) in Taxes on goods and services in Czech Republic?
Give a very brief answer. -2.61e+11. What is the difference between the Taxes (in $) in Taxes on exports and Taxes (in $) in Taxes on income in Czech Republic?
Make the answer very short. -2.03e+11. What is the difference between the Taxes (in $) of Taxes on goods and services and Taxes (in $) of Taxes on income in Czech Republic?
Your answer should be very brief. 5.84e+1. What is the ratio of the Taxes (in $) of Taxes on revenue in Congo (Democratic) to that in Congo (Republic)?
Your response must be concise. 1.67. What is the ratio of the Taxes (in $) in Taxes on exports in Congo (Democratic) to that in Congo (Republic)?
Provide a succinct answer. 0.01. What is the ratio of the Taxes (in $) of Taxes on goods and services in Congo (Democratic) to that in Congo (Republic)?
Provide a short and direct response. 1.26. What is the ratio of the Taxes (in $) of Taxes on income in Congo (Democratic) to that in Congo (Republic)?
Ensure brevity in your answer.  0.2. What is the ratio of the Taxes (in $) of Taxes on revenue in Congo (Democratic) to that in Cote d'Ivoire?
Your response must be concise. 0.27. What is the ratio of the Taxes (in $) in Taxes on exports in Congo (Democratic) to that in Cote d'Ivoire?
Provide a succinct answer. 0.01. What is the ratio of the Taxes (in $) of Taxes on goods and services in Congo (Democratic) to that in Cote d'Ivoire?
Provide a short and direct response. 0.43. What is the ratio of the Taxes (in $) in Taxes on income in Congo (Democratic) to that in Cote d'Ivoire?
Your response must be concise. 9.27. What is the ratio of the Taxes (in $) in Taxes on revenue in Congo (Democratic) to that in Croatia?
Your answer should be compact. 6.28. What is the ratio of the Taxes (in $) in Taxes on exports in Congo (Democratic) to that in Croatia?
Your answer should be very brief. 0. What is the ratio of the Taxes (in $) of Taxes on goods and services in Congo (Democratic) to that in Croatia?
Provide a succinct answer. 2.43. What is the ratio of the Taxes (in $) in Taxes on income in Congo (Democratic) to that in Croatia?
Ensure brevity in your answer.  33.37. What is the ratio of the Taxes (in $) in Taxes on revenue in Congo (Democratic) to that in Cyprus?
Your answer should be compact. 54.88. What is the ratio of the Taxes (in $) of Taxes on goods and services in Congo (Democratic) to that in Cyprus?
Your answer should be compact. 30.64. What is the ratio of the Taxes (in $) in Taxes on income in Congo (Democratic) to that in Cyprus?
Keep it short and to the point. 0.34. What is the ratio of the Taxes (in $) of Taxes on revenue in Congo (Democratic) to that in Czech Republic?
Ensure brevity in your answer.  0.72. What is the ratio of the Taxes (in $) in Taxes on exports in Congo (Democratic) to that in Czech Republic?
Offer a terse response. 8.52. What is the ratio of the Taxes (in $) of Taxes on goods and services in Congo (Democratic) to that in Czech Republic?
Ensure brevity in your answer.  0.41. What is the ratio of the Taxes (in $) in Taxes on income in Congo (Democratic) to that in Czech Republic?
Your response must be concise. 0.32. What is the ratio of the Taxes (in $) in Taxes on revenue in Congo (Republic) to that in Cote d'Ivoire?
Ensure brevity in your answer.  0.16. What is the ratio of the Taxes (in $) of Taxes on exports in Congo (Republic) to that in Cote d'Ivoire?
Offer a very short reply. 1.02. What is the ratio of the Taxes (in $) of Taxes on goods and services in Congo (Republic) to that in Cote d'Ivoire?
Keep it short and to the point. 0.34. What is the ratio of the Taxes (in $) of Taxes on income in Congo (Republic) to that in Cote d'Ivoire?
Your answer should be very brief. 46.14. What is the ratio of the Taxes (in $) of Taxes on revenue in Congo (Republic) to that in Croatia?
Your answer should be compact. 3.75. What is the ratio of the Taxes (in $) of Taxes on exports in Congo (Republic) to that in Croatia?
Provide a succinct answer. 0.06. What is the ratio of the Taxes (in $) in Taxes on goods and services in Congo (Republic) to that in Croatia?
Your response must be concise. 1.93. What is the ratio of the Taxes (in $) of Taxes on income in Congo (Republic) to that in Croatia?
Your answer should be very brief. 166.1. What is the ratio of the Taxes (in $) in Taxes on revenue in Congo (Republic) to that in Cyprus?
Keep it short and to the point. 32.77. What is the ratio of the Taxes (in $) of Taxes on goods and services in Congo (Republic) to that in Cyprus?
Ensure brevity in your answer.  24.28. What is the ratio of the Taxes (in $) of Taxes on income in Congo (Republic) to that in Cyprus?
Keep it short and to the point. 1.67. What is the ratio of the Taxes (in $) of Taxes on revenue in Congo (Republic) to that in Czech Republic?
Your answer should be very brief. 0.43. What is the ratio of the Taxes (in $) in Taxes on exports in Congo (Republic) to that in Czech Republic?
Provide a succinct answer. 709.9. What is the ratio of the Taxes (in $) in Taxes on goods and services in Congo (Republic) to that in Czech Republic?
Your answer should be compact. 0.33. What is the ratio of the Taxes (in $) of Taxes on income in Congo (Republic) to that in Czech Republic?
Provide a short and direct response. 1.61. What is the ratio of the Taxes (in $) of Taxes on revenue in Cote d'Ivoire to that in Croatia?
Offer a very short reply. 23.41. What is the ratio of the Taxes (in $) of Taxes on exports in Cote d'Ivoire to that in Croatia?
Make the answer very short. 0.06. What is the ratio of the Taxes (in $) in Taxes on goods and services in Cote d'Ivoire to that in Croatia?
Keep it short and to the point. 5.72. What is the ratio of the Taxes (in $) of Taxes on income in Cote d'Ivoire to that in Croatia?
Offer a very short reply. 3.6. What is the ratio of the Taxes (in $) of Taxes on revenue in Cote d'Ivoire to that in Cyprus?
Provide a short and direct response. 204.54. What is the ratio of the Taxes (in $) in Taxes on goods and services in Cote d'Ivoire to that in Cyprus?
Ensure brevity in your answer.  71.99. What is the ratio of the Taxes (in $) of Taxes on income in Cote d'Ivoire to that in Cyprus?
Ensure brevity in your answer.  0.04. What is the ratio of the Taxes (in $) in Taxes on revenue in Cote d'Ivoire to that in Czech Republic?
Offer a very short reply. 2.69. What is the ratio of the Taxes (in $) of Taxes on exports in Cote d'Ivoire to that in Czech Republic?
Ensure brevity in your answer.  697.9. What is the ratio of the Taxes (in $) of Taxes on goods and services in Cote d'Ivoire to that in Czech Republic?
Provide a succinct answer. 0.97. What is the ratio of the Taxes (in $) of Taxes on income in Cote d'Ivoire to that in Czech Republic?
Offer a very short reply. 0.03. What is the ratio of the Taxes (in $) in Taxes on revenue in Croatia to that in Cyprus?
Ensure brevity in your answer.  8.74. What is the ratio of the Taxes (in $) of Taxes on exports in Croatia to that in Cyprus?
Your response must be concise. 0.01. What is the ratio of the Taxes (in $) in Taxes on goods and services in Croatia to that in Cyprus?
Your answer should be compact. 12.58. What is the ratio of the Taxes (in $) of Taxes on income in Croatia to that in Cyprus?
Keep it short and to the point. 0.01. What is the ratio of the Taxes (in $) of Taxes on revenue in Croatia to that in Czech Republic?
Ensure brevity in your answer.  0.12. What is the ratio of the Taxes (in $) in Taxes on exports in Croatia to that in Czech Republic?
Your answer should be very brief. 1.20e+04. What is the ratio of the Taxes (in $) of Taxes on goods and services in Croatia to that in Czech Republic?
Offer a very short reply. 0.17. What is the ratio of the Taxes (in $) in Taxes on income in Croatia to that in Czech Republic?
Keep it short and to the point. 0.01. What is the ratio of the Taxes (in $) of Taxes on revenue in Cyprus to that in Czech Republic?
Offer a terse response. 0.01. What is the ratio of the Taxes (in $) of Taxes on exports in Cyprus to that in Czech Republic?
Keep it short and to the point. 1.35e+06. What is the ratio of the Taxes (in $) in Taxes on goods and services in Cyprus to that in Czech Republic?
Offer a very short reply. 0.01. What is the ratio of the Taxes (in $) in Taxes on income in Cyprus to that in Czech Republic?
Your answer should be very brief. 0.96. What is the difference between the highest and the second highest Taxes (in $) in Taxes on revenue?
Your answer should be compact. 7.87e+11. What is the difference between the highest and the second highest Taxes (in $) in Taxes on exports?
Your answer should be very brief. 1.34e+12. What is the difference between the highest and the second highest Taxes (in $) in Taxes on goods and services?
Give a very brief answer. 8.94e+09. What is the difference between the highest and the second highest Taxes (in $) in Taxes on income?
Provide a succinct answer. 1.23e+11. What is the difference between the highest and the lowest Taxes (in $) in Taxes on revenue?
Make the answer very short. 1.25e+12. What is the difference between the highest and the lowest Taxes (in $) of Taxes on exports?
Offer a terse response. 1.35e+12. What is the difference between the highest and the lowest Taxes (in $) of Taxes on goods and services?
Offer a very short reply. 2.58e+11. What is the difference between the highest and the lowest Taxes (in $) in Taxes on income?
Provide a short and direct response. 3.24e+11. 